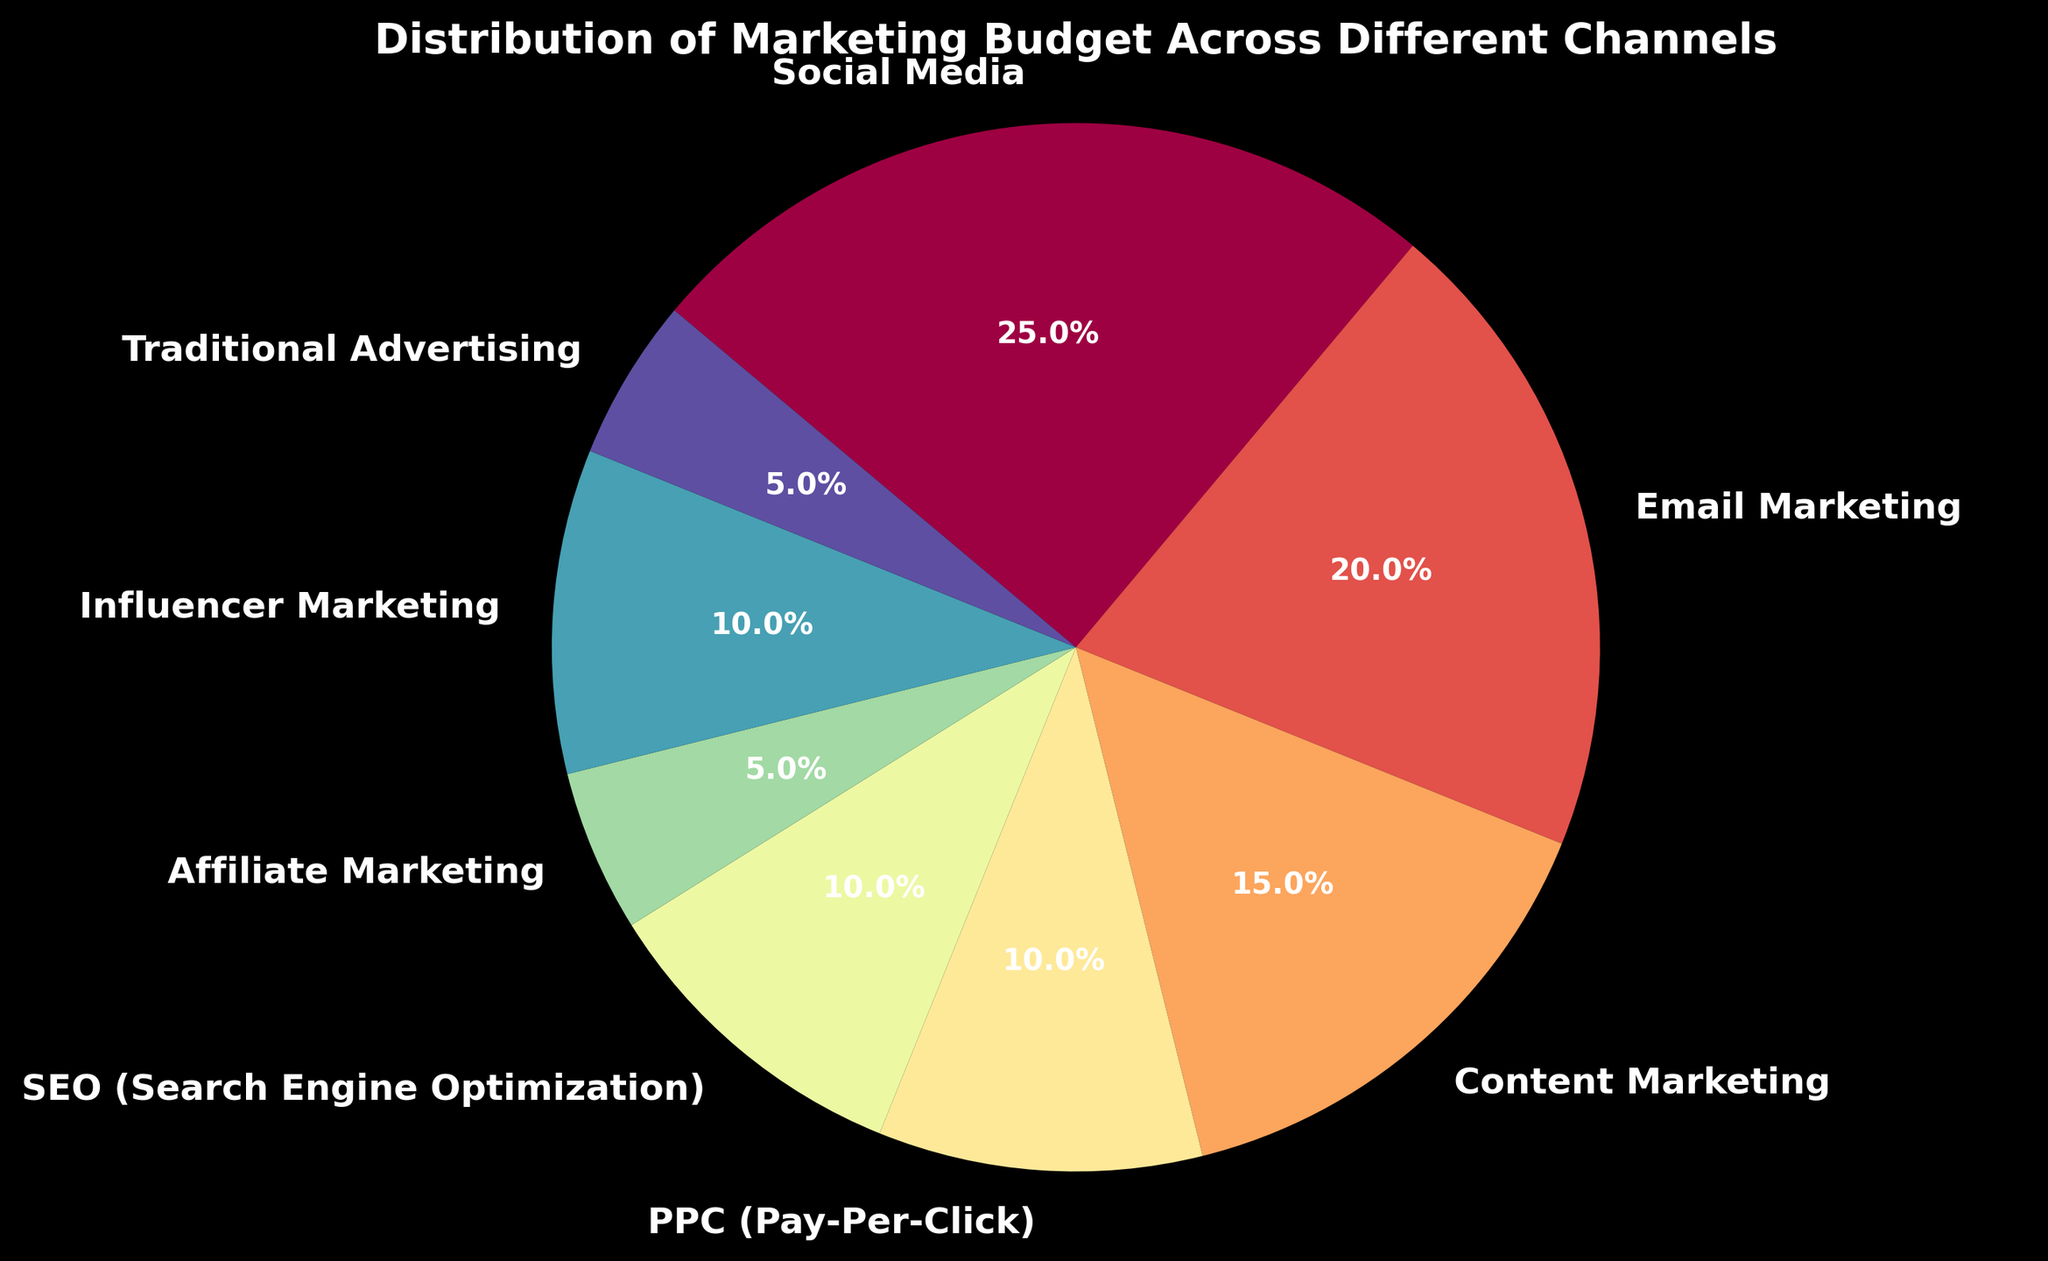What is the largest budgeted marketing channel? The largest slice of the pie chart represents the channel with the highest budget. In this chart, the largest slice corresponds to Social Media, which shows 25%.
Answer: Social Media Which two channels have equal budget percentages? By looking at the pie chart, we see that SEO and Influencer Marketing both have slices labeled with 10%.
Answer: SEO and Influencer Marketing What percentage of the budget is allocated to Email Marketing and PPC combined? First, find the percentages for both Email Marketing (20%) and PPC (10%) from the chart. Add the two percentages together: 20% + 10% = 30%.
Answer: 30% Is the budget for Content Marketing greater than that for PPC and Affiliate Marketing combined? The budget for Content Marketing is 15%. The combined budget for PPC (10%) and Affiliate Marketing (5%) is 10% + 5% = 15%. Hence, the budgets are equal, not greater.
Answer: No Which channel has half the percentage of the budget compared to Social Media? Social Media is allocated 25%. Half of 25% is 12.5%. None of the channels match exactly 12.5%, but Content Marketing is the closest with 15%. Thus, strictly speaking, the answer is none.
Answer: None Which channels have a budget allocation of less than 10%? By examining the pie chart slices, we can see that Affiliate Marketing and Traditional Advertising both have percentages below 10%, specifically 5% each.
Answer: Affiliate Marketing and Traditional Advertising What fraction of the total budget is allocated to Social Media, Email Marketing, and SEO combined? Sum the individual percentages: Social Media (25%), Email Marketing (20%), and SEO (10%). Adding these together: 25% + 20% + 10% = 55%. Since we are dealing with a pie chart, and the total is 100%, 55% represents the fraction 55/100 which simplifies to 11/20.
Answer: 11/20 